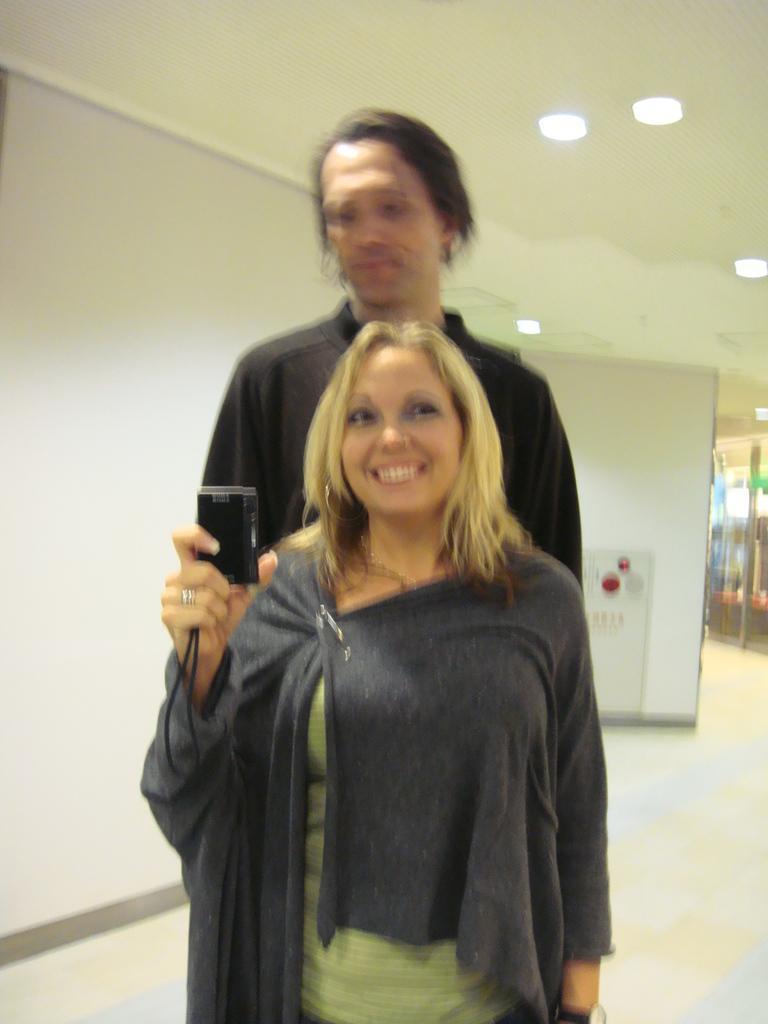Please provide a concise description of this image. In this image in front there is a person wearing a smile on her smile and she is holding some object. Behind her there is another person. In the background of the image there is a wall. On the right side of the image there is a glass door. At the bottom of the image there is a floor. On top of the image there are lights. 